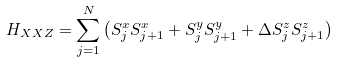Convert formula to latex. <formula><loc_0><loc_0><loc_500><loc_500>H _ { X X Z } = \sum _ { j = 1 } ^ { N } \left ( S _ { j } ^ { x } S _ { j + 1 } ^ { x } + S _ { j } ^ { y } S _ { j + 1 } ^ { y } + \Delta S _ { j } ^ { z } S _ { j + 1 } ^ { z } \right )</formula> 